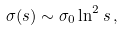Convert formula to latex. <formula><loc_0><loc_0><loc_500><loc_500>\sigma ( s ) \sim \sigma _ { 0 } \ln ^ { 2 } s \, ,</formula> 